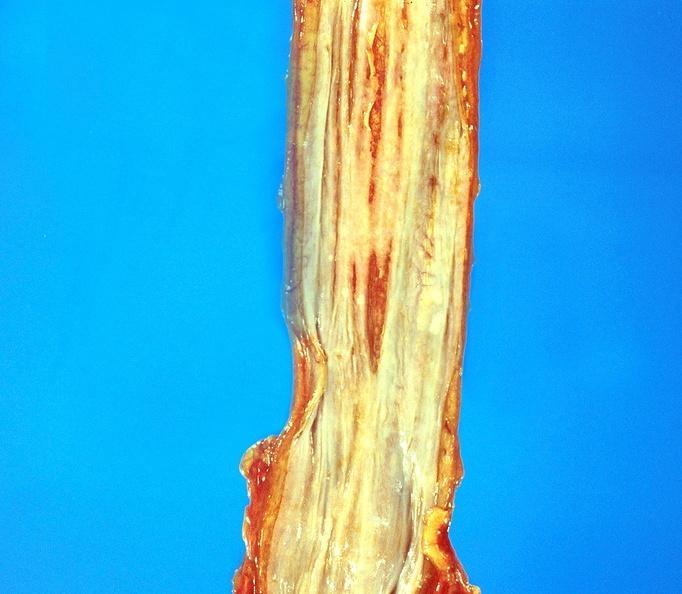what does this image show?
Answer the question using a single word or phrase. Esophageal varices 